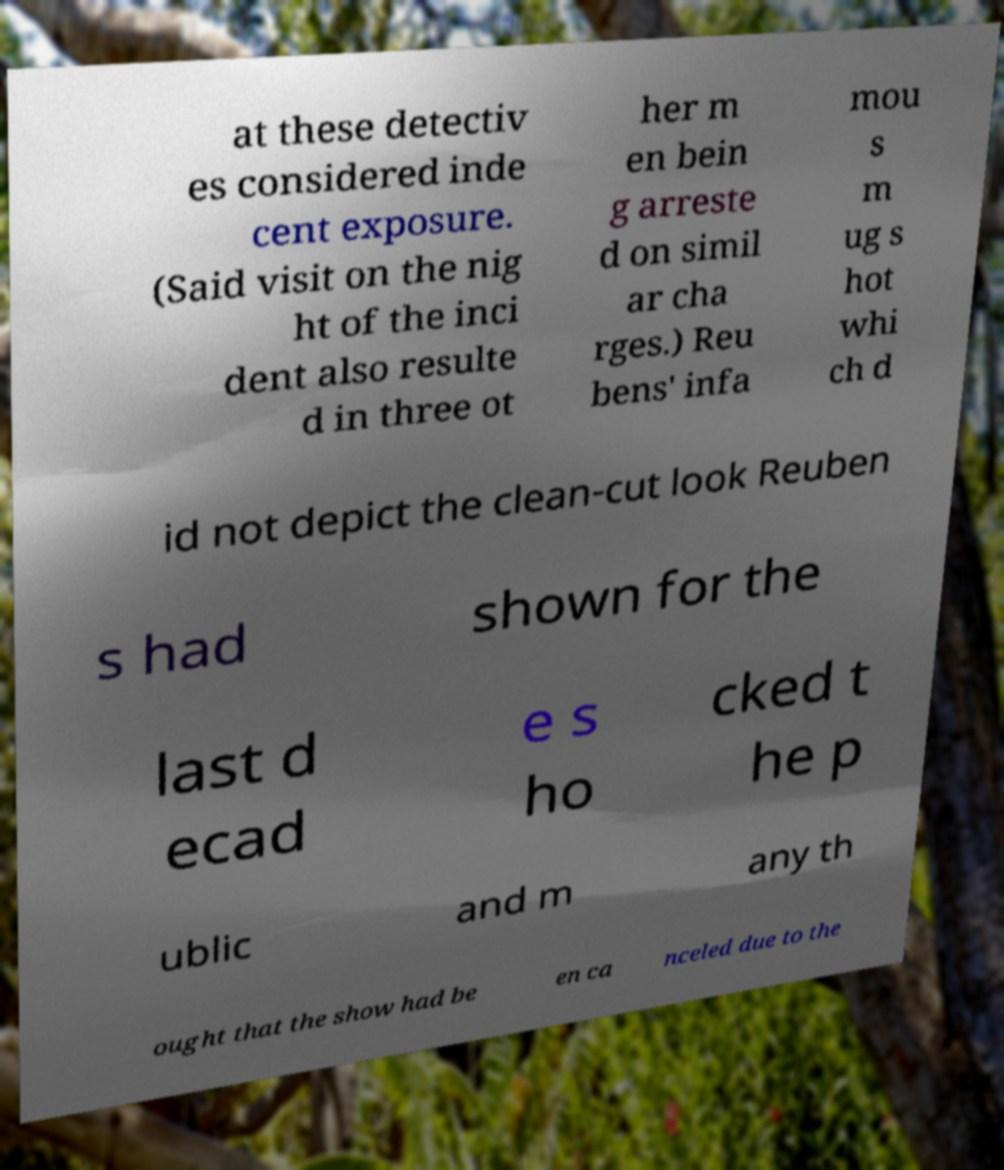For documentation purposes, I need the text within this image transcribed. Could you provide that? at these detectiv es considered inde cent exposure. (Said visit on the nig ht of the inci dent also resulte d in three ot her m en bein g arreste d on simil ar cha rges.) Reu bens' infa mou s m ug s hot whi ch d id not depict the clean-cut look Reuben s had shown for the last d ecad e s ho cked t he p ublic and m any th ought that the show had be en ca nceled due to the 